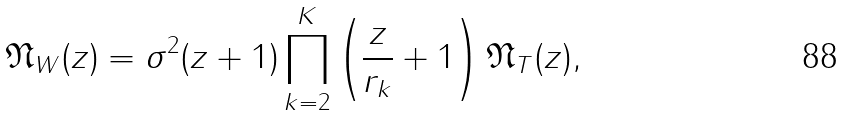Convert formula to latex. <formula><loc_0><loc_0><loc_500><loc_500>\mathfrak { N } _ { W } ( z ) = \sigma ^ { 2 } ( z + 1 ) \prod _ { k = 2 } ^ { K } \left ( \frac { z } { r _ { k } } + 1 \right ) \mathfrak { N } _ { T } ( z ) ,</formula> 